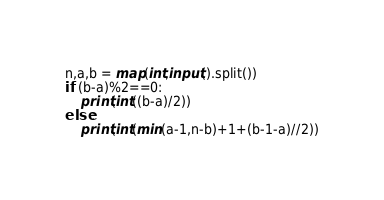<code> <loc_0><loc_0><loc_500><loc_500><_Python_>n,a,b = map(int,input().split())
if (b-a)%2==0:
    print(int((b-a)/2))
else:
    print(int(min(a-1,n-b)+1+(b-1-a)//2))</code> 